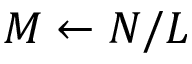<formula> <loc_0><loc_0><loc_500><loc_500>M \gets N / L</formula> 